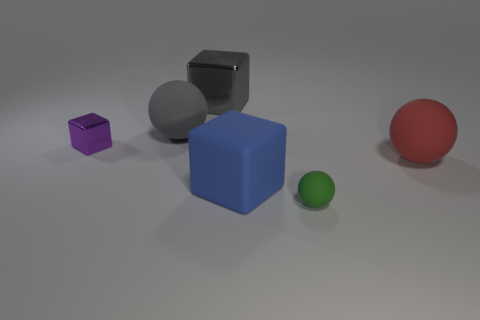What is the size of the matte object that is left of the big rubber thing in front of the big rubber ball that is right of the matte block?
Your answer should be very brief. Large. Is the large gray rubber object the same shape as the blue rubber object?
Provide a short and direct response. No. What size is the cube that is both in front of the gray rubber ball and right of the tiny metallic block?
Your response must be concise. Large. What material is the gray object that is the same shape as the green object?
Offer a terse response. Rubber. What is the big block that is on the left side of the block that is in front of the big red sphere made of?
Your answer should be very brief. Metal. Do the tiny purple thing and the big matte object that is in front of the red thing have the same shape?
Provide a short and direct response. Yes. What number of metal things are either small brown blocks or red balls?
Your answer should be compact. 0. What is the color of the small thing that is on the left side of the big rubber ball that is to the left of the tiny object on the right side of the large blue rubber thing?
Offer a terse response. Purple. What number of other objects are the same material as the small cube?
Your response must be concise. 1. Is the shape of the small object that is in front of the big red rubber sphere the same as  the small shiny object?
Give a very brief answer. No. 